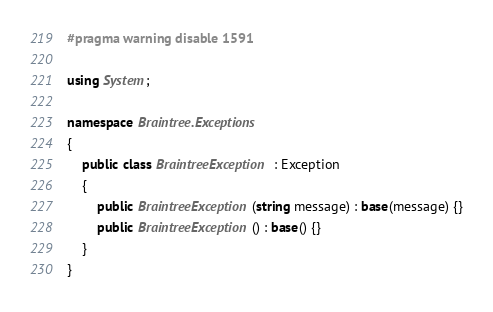<code> <loc_0><loc_0><loc_500><loc_500><_C#_>#pragma warning disable 1591

using System;

namespace Braintree.Exceptions
{
    public class BraintreeException : Exception
    {
        public BraintreeException(string message) : base(message) {}
        public BraintreeException() : base() {}
    }
}
</code> 